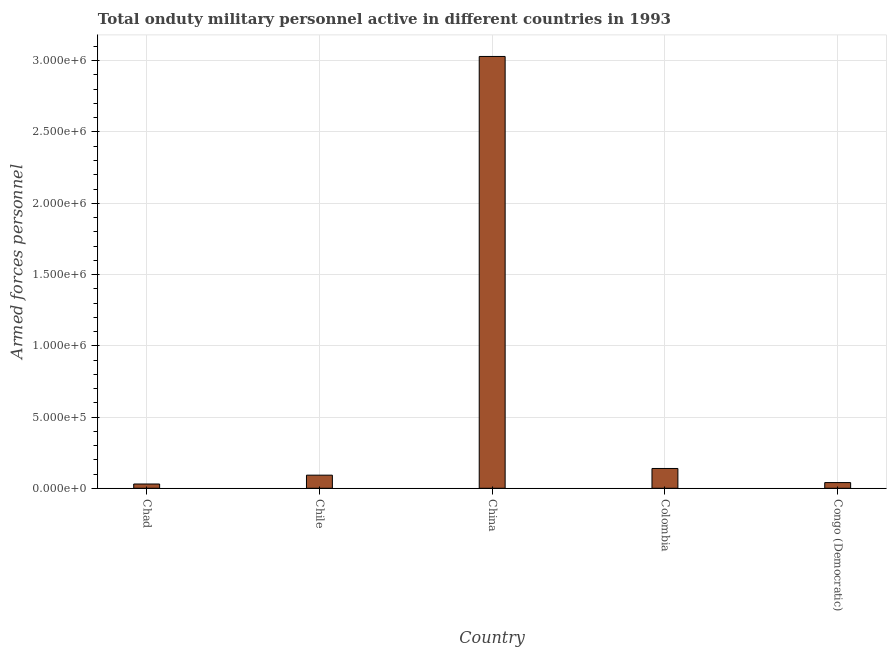Does the graph contain any zero values?
Your answer should be compact. No. What is the title of the graph?
Keep it short and to the point. Total onduty military personnel active in different countries in 1993. What is the label or title of the X-axis?
Your response must be concise. Country. What is the label or title of the Y-axis?
Your response must be concise. Armed forces personnel. Across all countries, what is the maximum number of armed forces personnel?
Ensure brevity in your answer.  3.03e+06. Across all countries, what is the minimum number of armed forces personnel?
Your answer should be very brief. 3.00e+04. In which country was the number of armed forces personnel maximum?
Offer a very short reply. China. In which country was the number of armed forces personnel minimum?
Give a very brief answer. Chad. What is the sum of the number of armed forces personnel?
Keep it short and to the point. 3.33e+06. What is the difference between the number of armed forces personnel in China and Congo (Democratic)?
Provide a succinct answer. 2.99e+06. What is the average number of armed forces personnel per country?
Offer a very short reply. 6.66e+05. What is the median number of armed forces personnel?
Provide a succinct answer. 9.20e+04. Is the number of armed forces personnel in Chad less than that in China?
Your answer should be compact. Yes. Is the difference between the number of armed forces personnel in China and Colombia greater than the difference between any two countries?
Provide a short and direct response. No. What is the difference between the highest and the second highest number of armed forces personnel?
Provide a succinct answer. 2.89e+06. Is the sum of the number of armed forces personnel in Chile and Colombia greater than the maximum number of armed forces personnel across all countries?
Keep it short and to the point. No. In how many countries, is the number of armed forces personnel greater than the average number of armed forces personnel taken over all countries?
Provide a succinct answer. 1. Are all the bars in the graph horizontal?
Give a very brief answer. No. Are the values on the major ticks of Y-axis written in scientific E-notation?
Provide a succinct answer. Yes. What is the Armed forces personnel in Chile?
Keep it short and to the point. 9.20e+04. What is the Armed forces personnel in China?
Keep it short and to the point. 3.03e+06. What is the Armed forces personnel of Colombia?
Offer a very short reply. 1.39e+05. What is the Armed forces personnel in Congo (Democratic)?
Ensure brevity in your answer.  4.00e+04. What is the difference between the Armed forces personnel in Chad and Chile?
Your response must be concise. -6.20e+04. What is the difference between the Armed forces personnel in Chad and China?
Your answer should be compact. -3.00e+06. What is the difference between the Armed forces personnel in Chad and Colombia?
Make the answer very short. -1.09e+05. What is the difference between the Armed forces personnel in Chad and Congo (Democratic)?
Ensure brevity in your answer.  -10000. What is the difference between the Armed forces personnel in Chile and China?
Provide a short and direct response. -2.94e+06. What is the difference between the Armed forces personnel in Chile and Colombia?
Ensure brevity in your answer.  -4.70e+04. What is the difference between the Armed forces personnel in Chile and Congo (Democratic)?
Make the answer very short. 5.20e+04. What is the difference between the Armed forces personnel in China and Colombia?
Provide a short and direct response. 2.89e+06. What is the difference between the Armed forces personnel in China and Congo (Democratic)?
Your answer should be very brief. 2.99e+06. What is the difference between the Armed forces personnel in Colombia and Congo (Democratic)?
Your answer should be very brief. 9.90e+04. What is the ratio of the Armed forces personnel in Chad to that in Chile?
Make the answer very short. 0.33. What is the ratio of the Armed forces personnel in Chad to that in Colombia?
Ensure brevity in your answer.  0.22. What is the ratio of the Armed forces personnel in Chad to that in Congo (Democratic)?
Provide a succinct answer. 0.75. What is the ratio of the Armed forces personnel in Chile to that in China?
Your response must be concise. 0.03. What is the ratio of the Armed forces personnel in Chile to that in Colombia?
Provide a short and direct response. 0.66. What is the ratio of the Armed forces personnel in China to that in Colombia?
Your response must be concise. 21.8. What is the ratio of the Armed forces personnel in China to that in Congo (Democratic)?
Your answer should be compact. 75.75. What is the ratio of the Armed forces personnel in Colombia to that in Congo (Democratic)?
Provide a short and direct response. 3.48. 